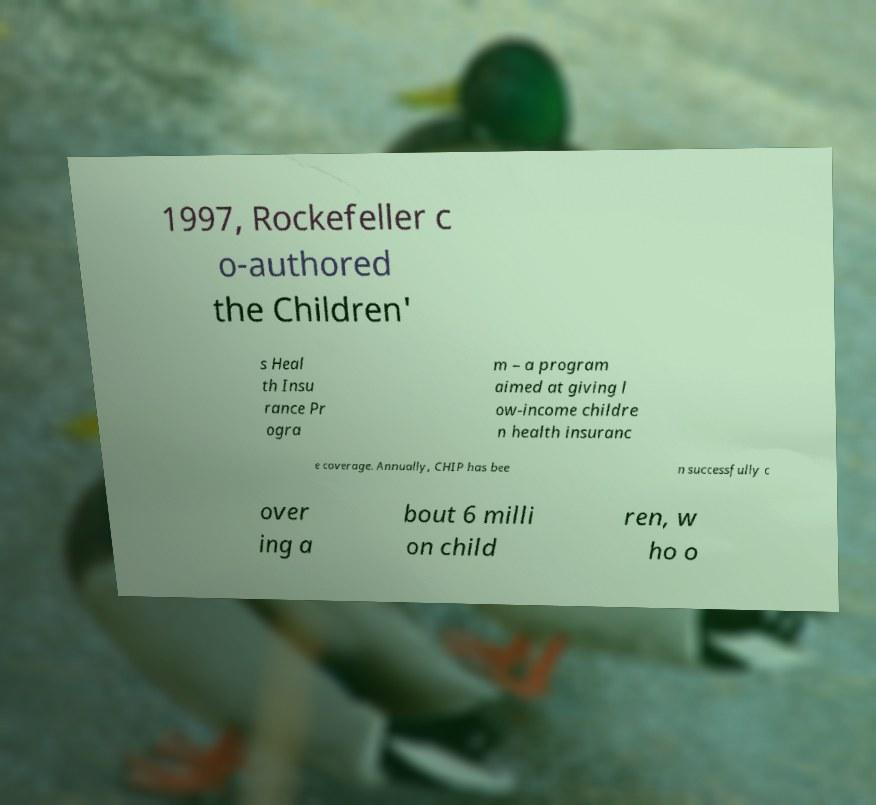For documentation purposes, I need the text within this image transcribed. Could you provide that? 1997, Rockefeller c o-authored the Children' s Heal th Insu rance Pr ogra m – a program aimed at giving l ow-income childre n health insuranc e coverage. Annually, CHIP has bee n successfully c over ing a bout 6 milli on child ren, w ho o 